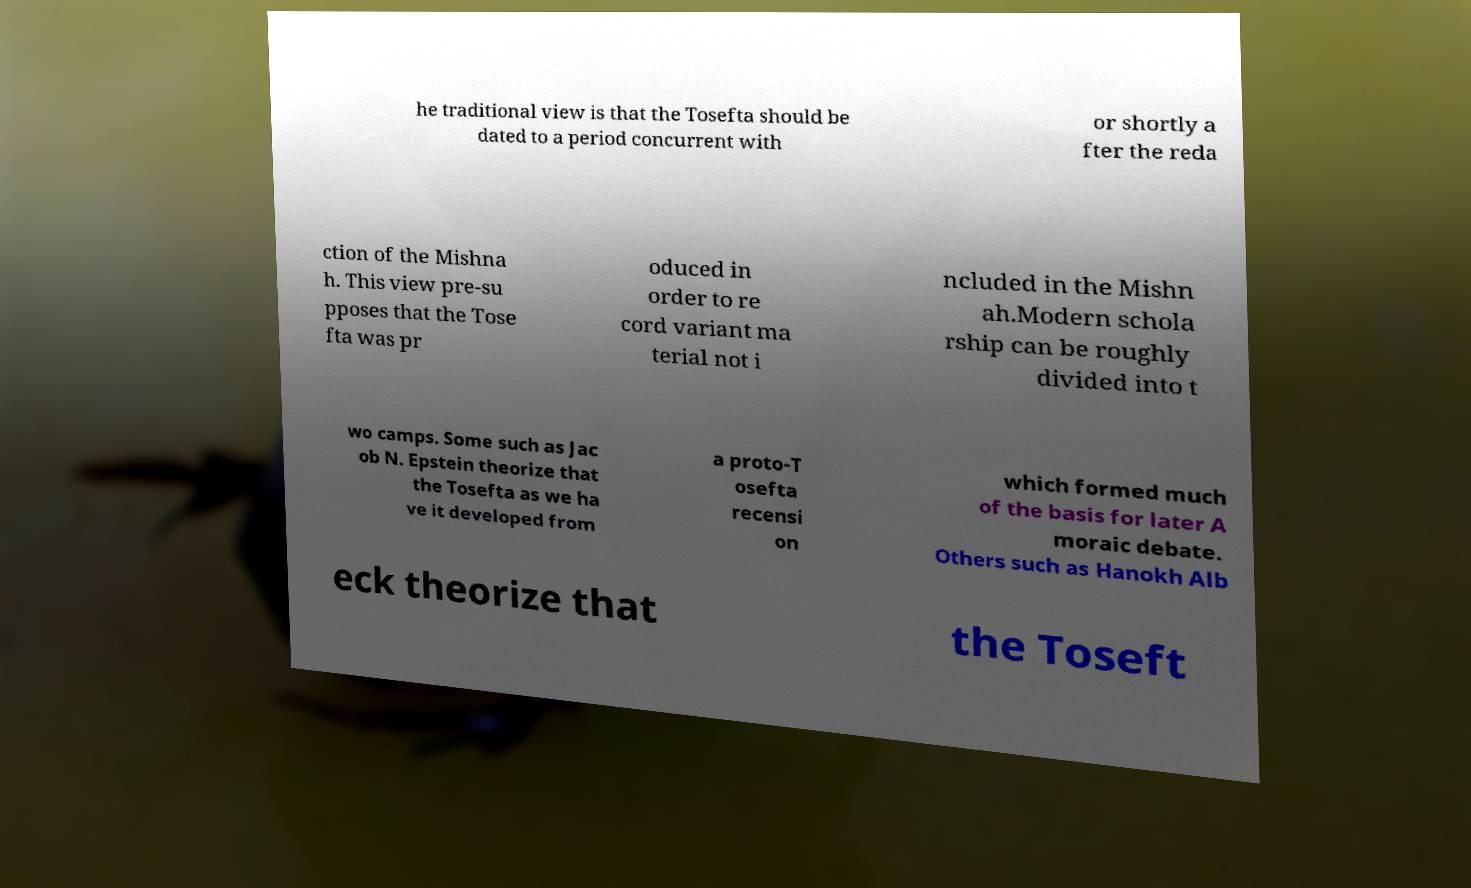I need the written content from this picture converted into text. Can you do that? he traditional view is that the Tosefta should be dated to a period concurrent with or shortly a fter the reda ction of the Mishna h. This view pre-su pposes that the Tose fta was pr oduced in order to re cord variant ma terial not i ncluded in the Mishn ah.Modern schola rship can be roughly divided into t wo camps. Some such as Jac ob N. Epstein theorize that the Tosefta as we ha ve it developed from a proto-T osefta recensi on which formed much of the basis for later A moraic debate. Others such as Hanokh Alb eck theorize that the Toseft 